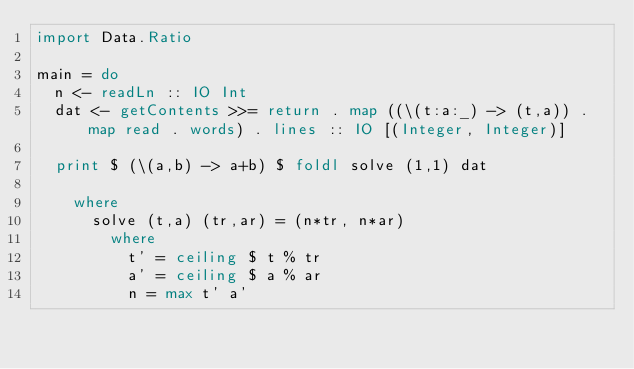<code> <loc_0><loc_0><loc_500><loc_500><_Haskell_>import Data.Ratio

main = do
  n <- readLn :: IO Int
  dat <- getContents >>= return . map ((\(t:a:_) -> (t,a)) . map read . words) . lines :: IO [(Integer, Integer)]

  print $ (\(a,b) -> a+b) $ foldl solve (1,1) dat

    where
      solve (t,a) (tr,ar) = (n*tr, n*ar)
        where
          t' = ceiling $ t % tr
          a' = ceiling $ a % ar
          n = max t' a'
</code> 